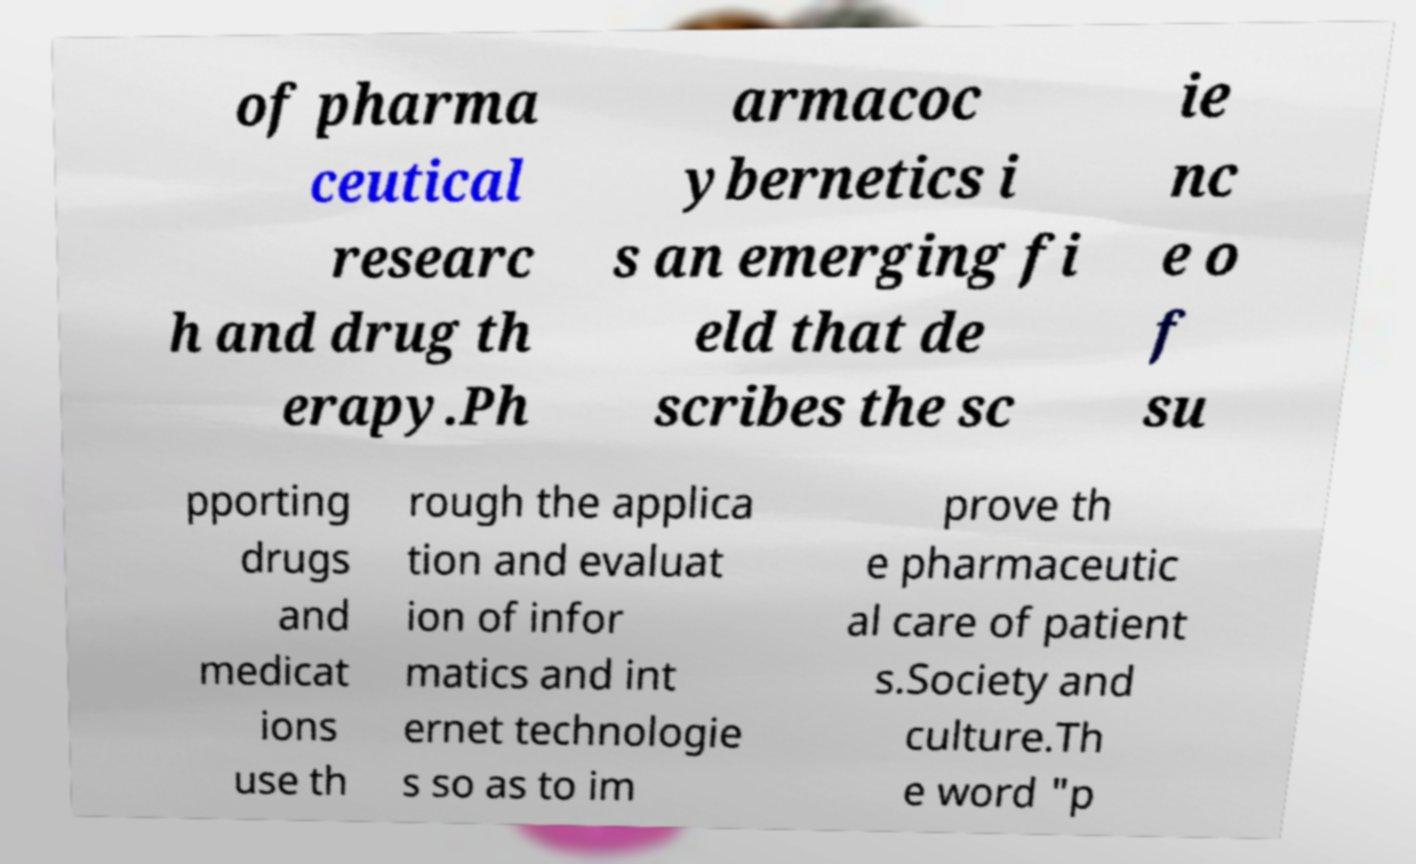I need the written content from this picture converted into text. Can you do that? of pharma ceutical researc h and drug th erapy.Ph armacoc ybernetics i s an emerging fi eld that de scribes the sc ie nc e o f su pporting drugs and medicat ions use th rough the applica tion and evaluat ion of infor matics and int ernet technologie s so as to im prove th e pharmaceutic al care of patient s.Society and culture.Th e word "p 